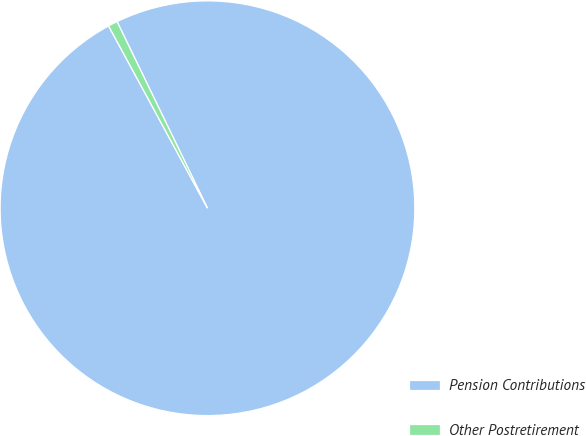Convert chart. <chart><loc_0><loc_0><loc_500><loc_500><pie_chart><fcel>Pension Contributions<fcel>Other Postretirement<nl><fcel>99.27%<fcel>0.73%<nl></chart> 